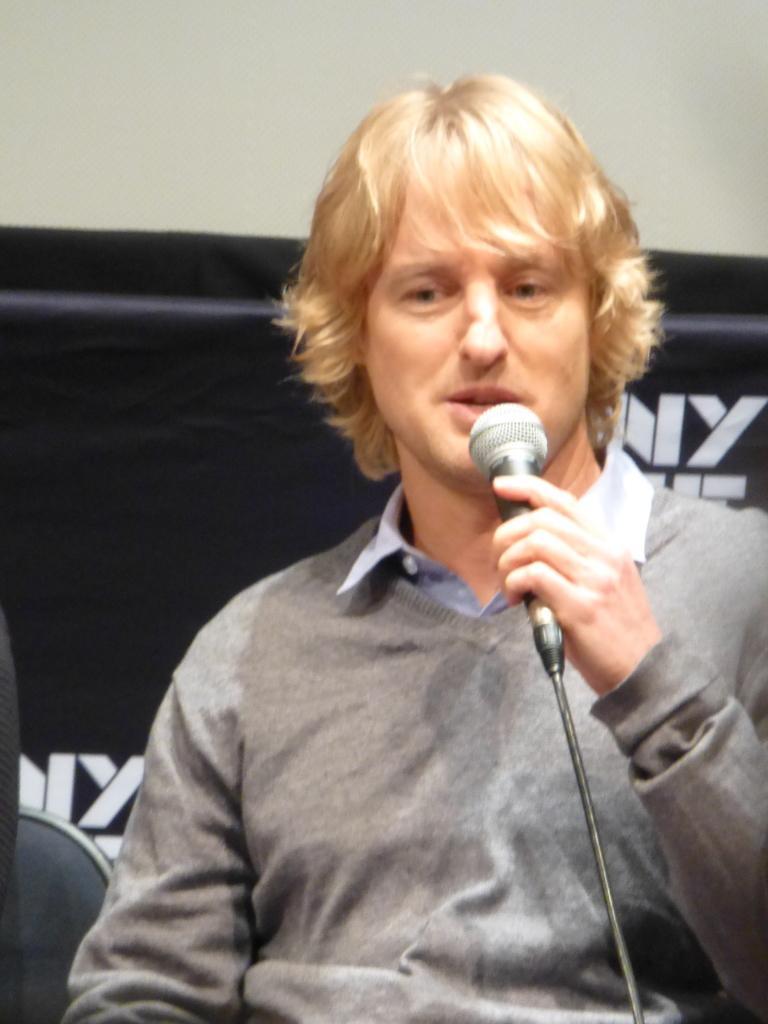In one or two sentences, can you explain what this image depicts? As we can see in the image there is a man holding mic. 